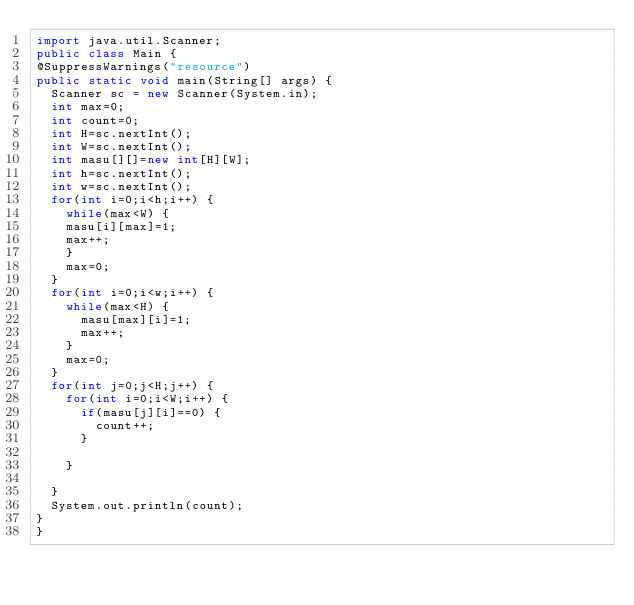Convert code to text. <code><loc_0><loc_0><loc_500><loc_500><_Java_>import java.util.Scanner;
public class Main {
@SuppressWarnings("resource")
public static void main(String[] args) {
	Scanner sc = new Scanner(System.in);
	int max=0;
	int count=0;
	int H=sc.nextInt();
	int W=sc.nextInt();
	int masu[][]=new int[H][W];
	int h=sc.nextInt();
	int w=sc.nextInt();
	for(int i=0;i<h;i++) {
		while(max<W) {
		masu[i][max]=1;
		max++;
		}
		max=0;
	}
	for(int i=0;i<w;i++) {
		while(max<H) {
			masu[max][i]=1;
			max++;
		}
		max=0;
	}
	for(int j=0;j<H;j++) {
		for(int i=0;i<W;i++) {
			if(masu[j][i]==0) {
				count++;
			}

		}

	}
	System.out.println(count);
}
}</code> 